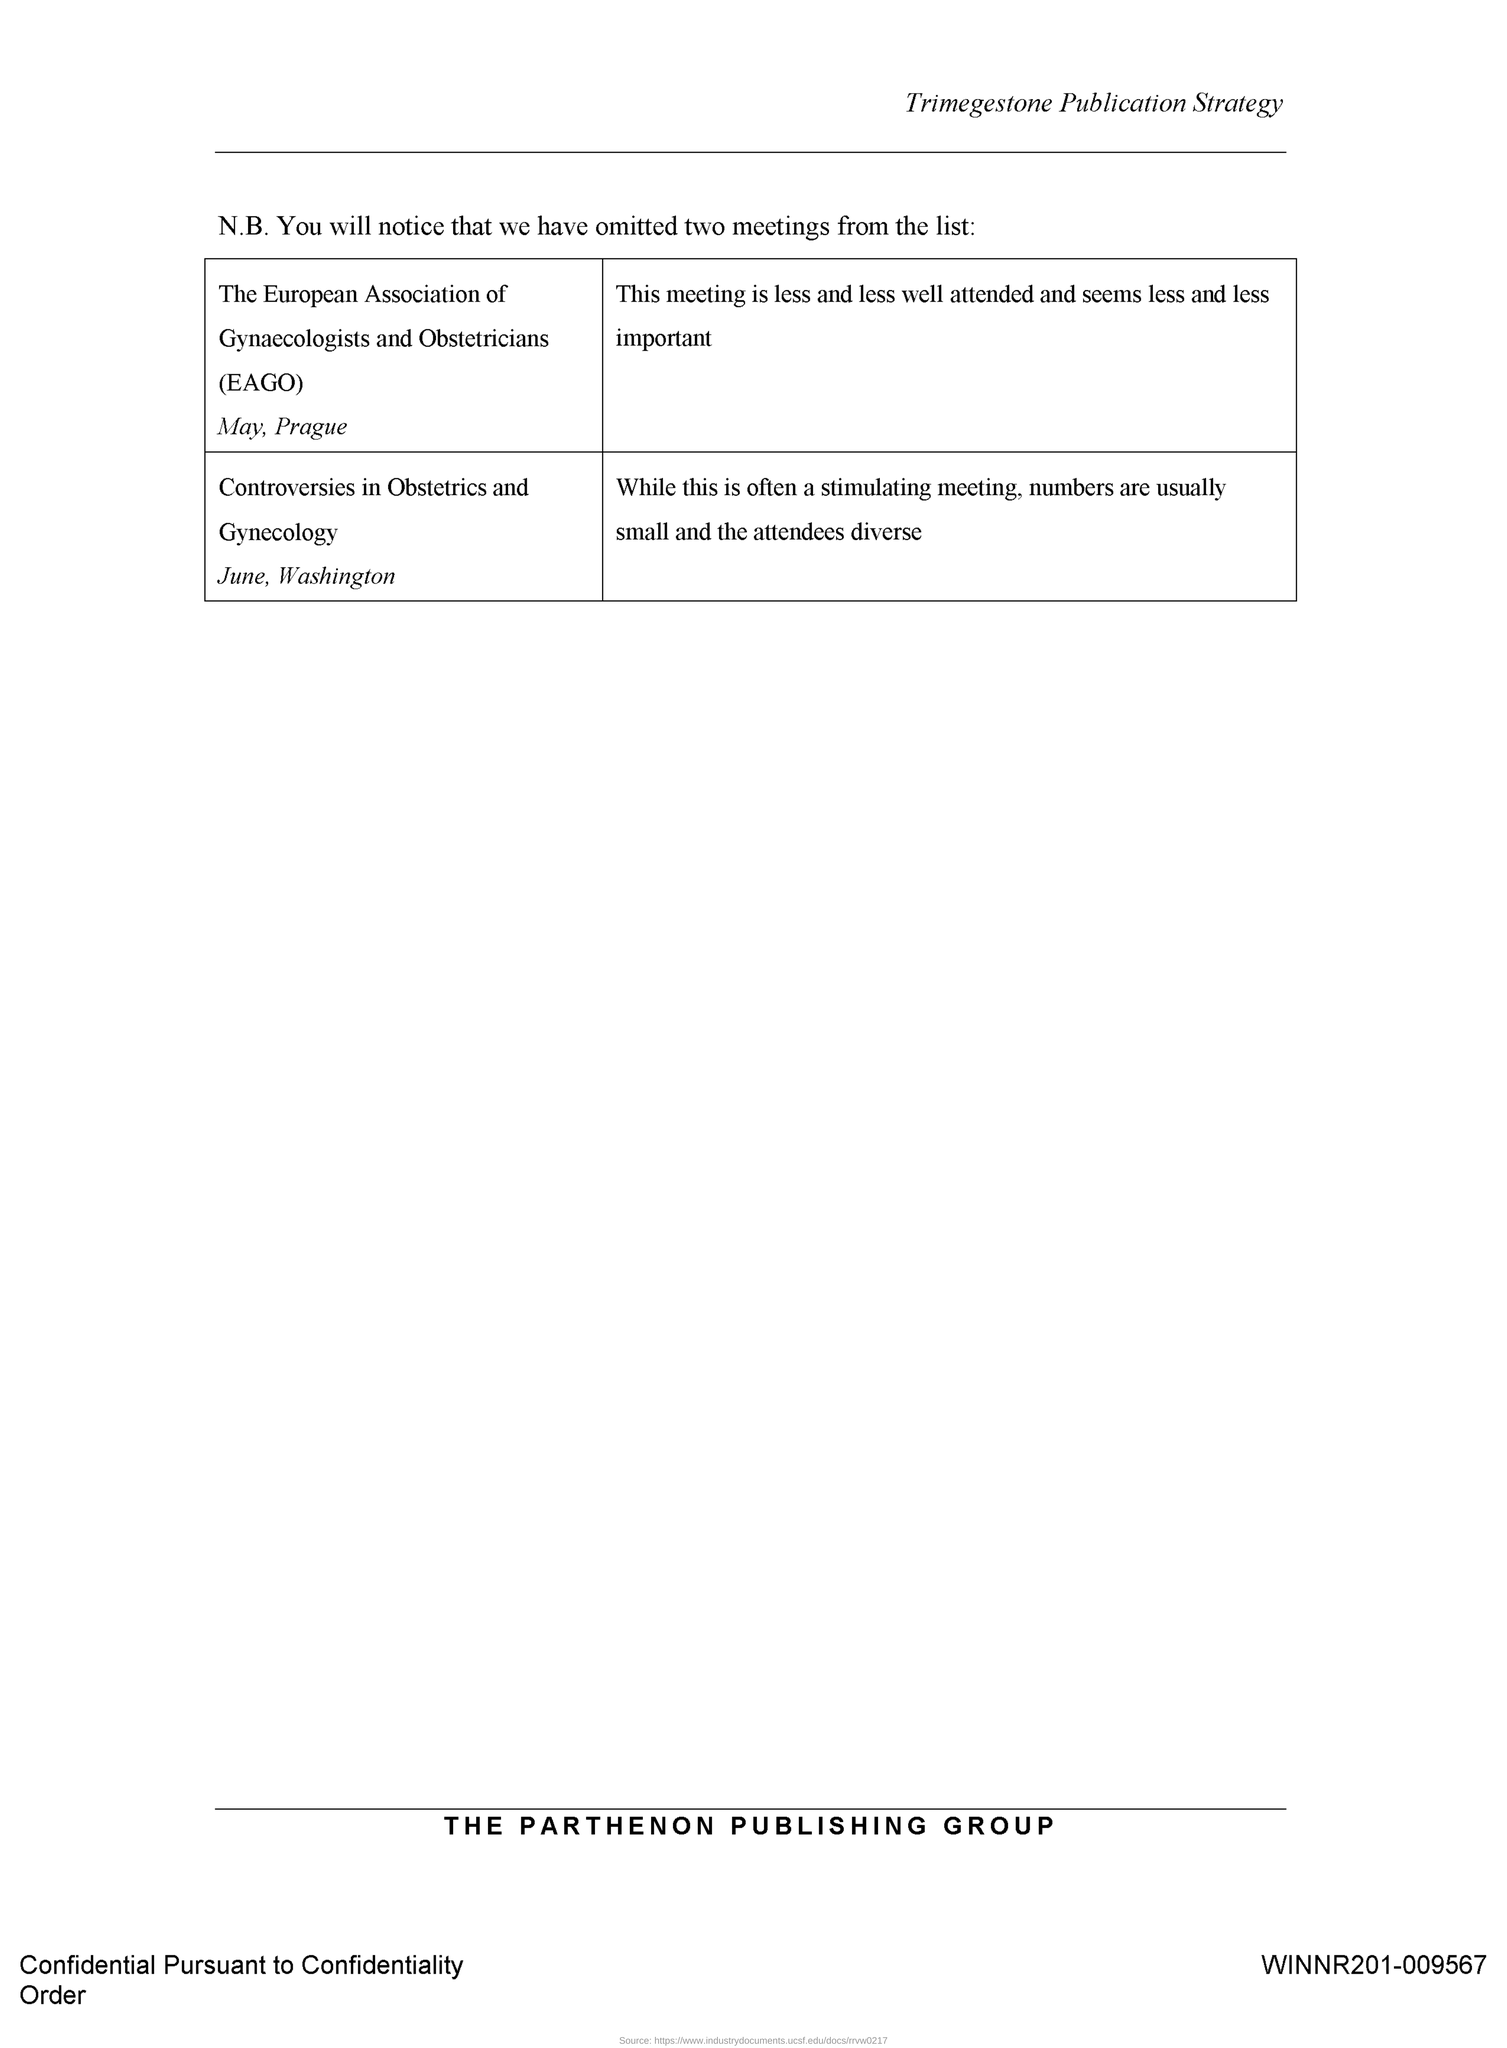Highlight a few significant elements in this photo. The meeting known as "Controversies in Obstetrics and Gynecology" is held in Washington. The meeting known as "Controversies in Obstetrics and Gynecology" is held in the month of June. The EAGO meeting is scheduled to be held in the month of May. The meeting EAGO is held in Prague. The full form of EAGO is the European Association of Gynecologists and Obstetricians. 